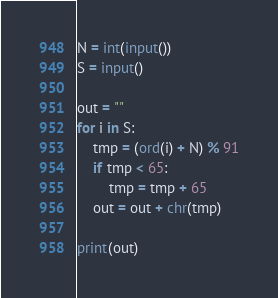<code> <loc_0><loc_0><loc_500><loc_500><_Python_>N = int(input())
S = input()

out = ""
for i in S:
    tmp = (ord(i) + N) % 91
    if tmp < 65:
        tmp = tmp + 65
    out = out + chr(tmp)

print(out)
</code> 